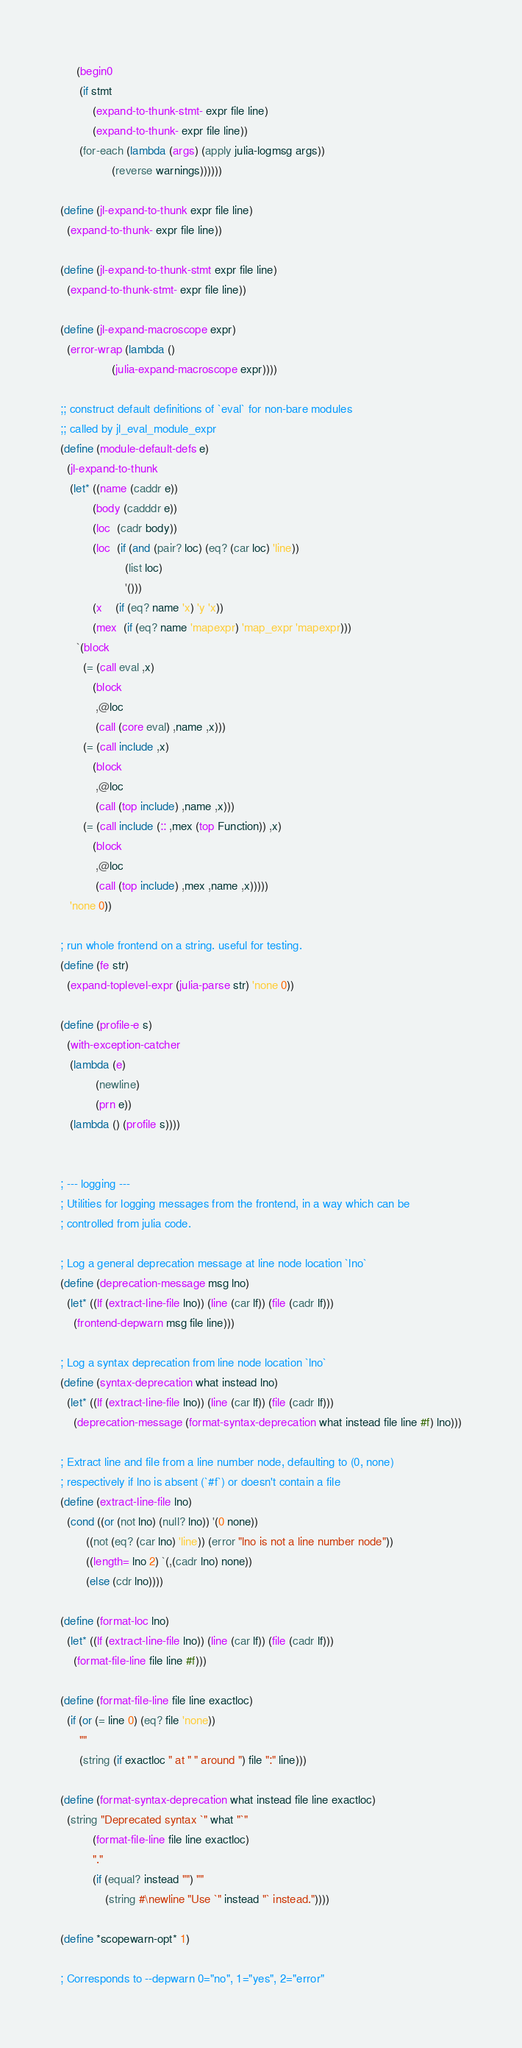Convert code to text. <code><loc_0><loc_0><loc_500><loc_500><_Scheme_>     (begin0
      (if stmt
          (expand-to-thunk-stmt- expr file line)
          (expand-to-thunk- expr file line))
      (for-each (lambda (args) (apply julia-logmsg args))
                (reverse warnings))))))

(define (jl-expand-to-thunk expr file line)
  (expand-to-thunk- expr file line))

(define (jl-expand-to-thunk-stmt expr file line)
  (expand-to-thunk-stmt- expr file line))

(define (jl-expand-macroscope expr)
  (error-wrap (lambda ()
                (julia-expand-macroscope expr))))

;; construct default definitions of `eval` for non-bare modules
;; called by jl_eval_module_expr
(define (module-default-defs e)
  (jl-expand-to-thunk
   (let* ((name (caddr e))
          (body (cadddr e))
          (loc  (cadr body))
          (loc  (if (and (pair? loc) (eq? (car loc) 'line))
                    (list loc)
                    '()))
          (x    (if (eq? name 'x) 'y 'x))
          (mex  (if (eq? name 'mapexpr) 'map_expr 'mapexpr)))
     `(block
       (= (call eval ,x)
          (block
           ,@loc
           (call (core eval) ,name ,x)))
       (= (call include ,x)
          (block
           ,@loc
           (call (top include) ,name ,x)))
       (= (call include (:: ,mex (top Function)) ,x)
          (block
           ,@loc
           (call (top include) ,mex ,name ,x)))))
   'none 0))

; run whole frontend on a string. useful for testing.
(define (fe str)
  (expand-toplevel-expr (julia-parse str) 'none 0))

(define (profile-e s)
  (with-exception-catcher
   (lambda (e)
           (newline)
           (prn e))
   (lambda () (profile s))))


; --- logging ---
; Utilities for logging messages from the frontend, in a way which can be
; controlled from julia code.

; Log a general deprecation message at line node location `lno`
(define (deprecation-message msg lno)
  (let* ((lf (extract-line-file lno)) (line (car lf)) (file (cadr lf)))
    (frontend-depwarn msg file line)))

; Log a syntax deprecation from line node location `lno`
(define (syntax-deprecation what instead lno)
  (let* ((lf (extract-line-file lno)) (line (car lf)) (file (cadr lf)))
    (deprecation-message (format-syntax-deprecation what instead file line #f) lno)))

; Extract line and file from a line number node, defaulting to (0, none)
; respectively if lno is absent (`#f`) or doesn't contain a file
(define (extract-line-file lno)
  (cond ((or (not lno) (null? lno)) '(0 none))
        ((not (eq? (car lno) 'line)) (error "lno is not a line number node"))
        ((length= lno 2) `(,(cadr lno) none))
        (else (cdr lno))))

(define (format-loc lno)
  (let* ((lf (extract-line-file lno)) (line (car lf)) (file (cadr lf)))
    (format-file-line file line #f)))

(define (format-file-line file line exactloc)
  (if (or (= line 0) (eq? file 'none))
      ""
      (string (if exactloc " at " " around ") file ":" line)))

(define (format-syntax-deprecation what instead file line exactloc)
  (string "Deprecated syntax `" what "`"
          (format-file-line file line exactloc)
          "."
          (if (equal? instead "") ""
              (string #\newline "Use `" instead "` instead."))))

(define *scopewarn-opt* 1)

; Corresponds to --depwarn 0="no", 1="yes", 2="error"</code> 